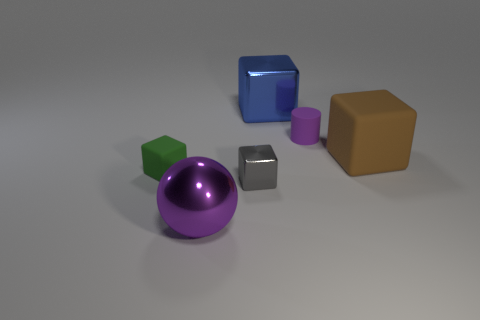There is a large object left of the blue metallic block; is its shape the same as the green object?
Offer a very short reply. No. Is the shape of the purple shiny object the same as the large blue thing?
Provide a succinct answer. No. Is there another small purple object of the same shape as the small purple thing?
Provide a succinct answer. No. What is the shape of the rubber thing to the left of the big thing in front of the small green rubber block?
Your answer should be compact. Cube. There is a tiny block that is left of the small gray shiny block; what color is it?
Keep it short and to the point. Green. What is the size of the green object that is made of the same material as the tiny cylinder?
Give a very brief answer. Small. The blue metal thing that is the same shape as the large brown object is what size?
Give a very brief answer. Large. Is there a large red rubber cube?
Provide a short and direct response. No. How many things are large objects that are behind the gray thing or green blocks?
Your answer should be compact. 3. There is a cylinder that is the same size as the gray object; what material is it?
Ensure brevity in your answer.  Rubber. 